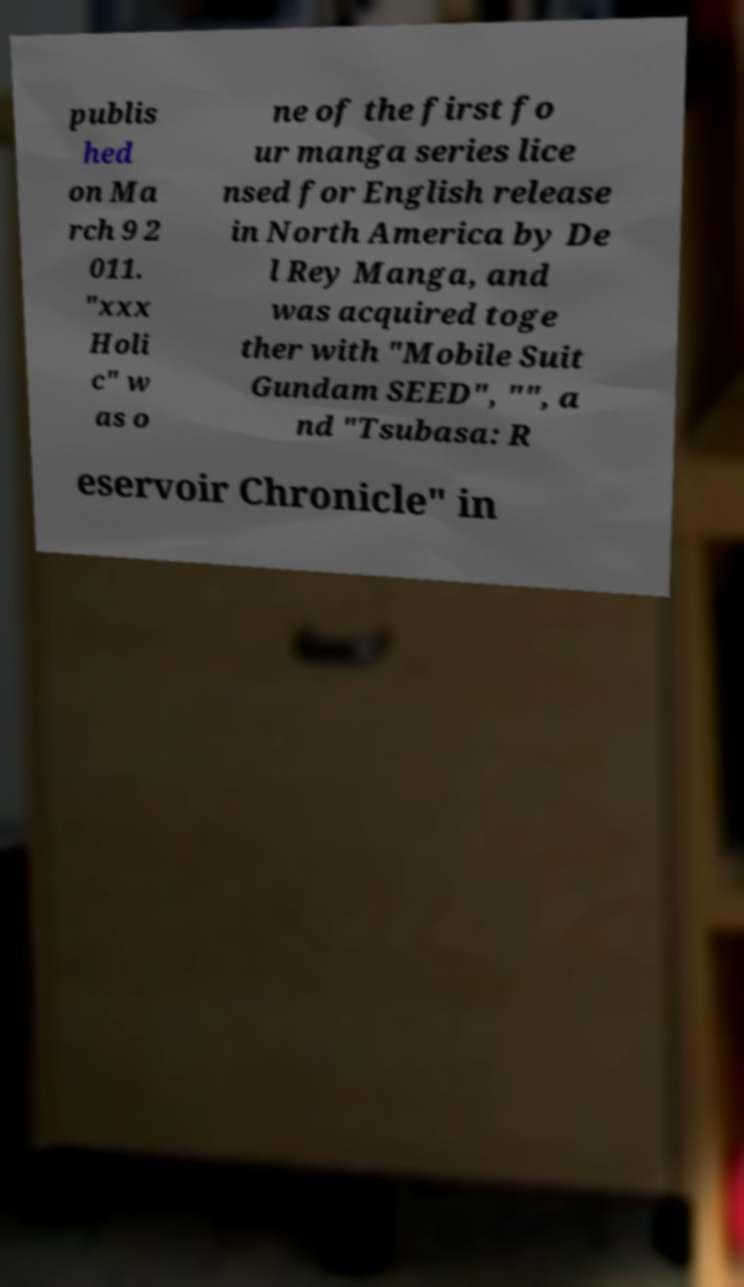Please identify and transcribe the text found in this image. publis hed on Ma rch 9 2 011. "xxx Holi c" w as o ne of the first fo ur manga series lice nsed for English release in North America by De l Rey Manga, and was acquired toge ther with "Mobile Suit Gundam SEED", "", a nd "Tsubasa: R eservoir Chronicle" in 